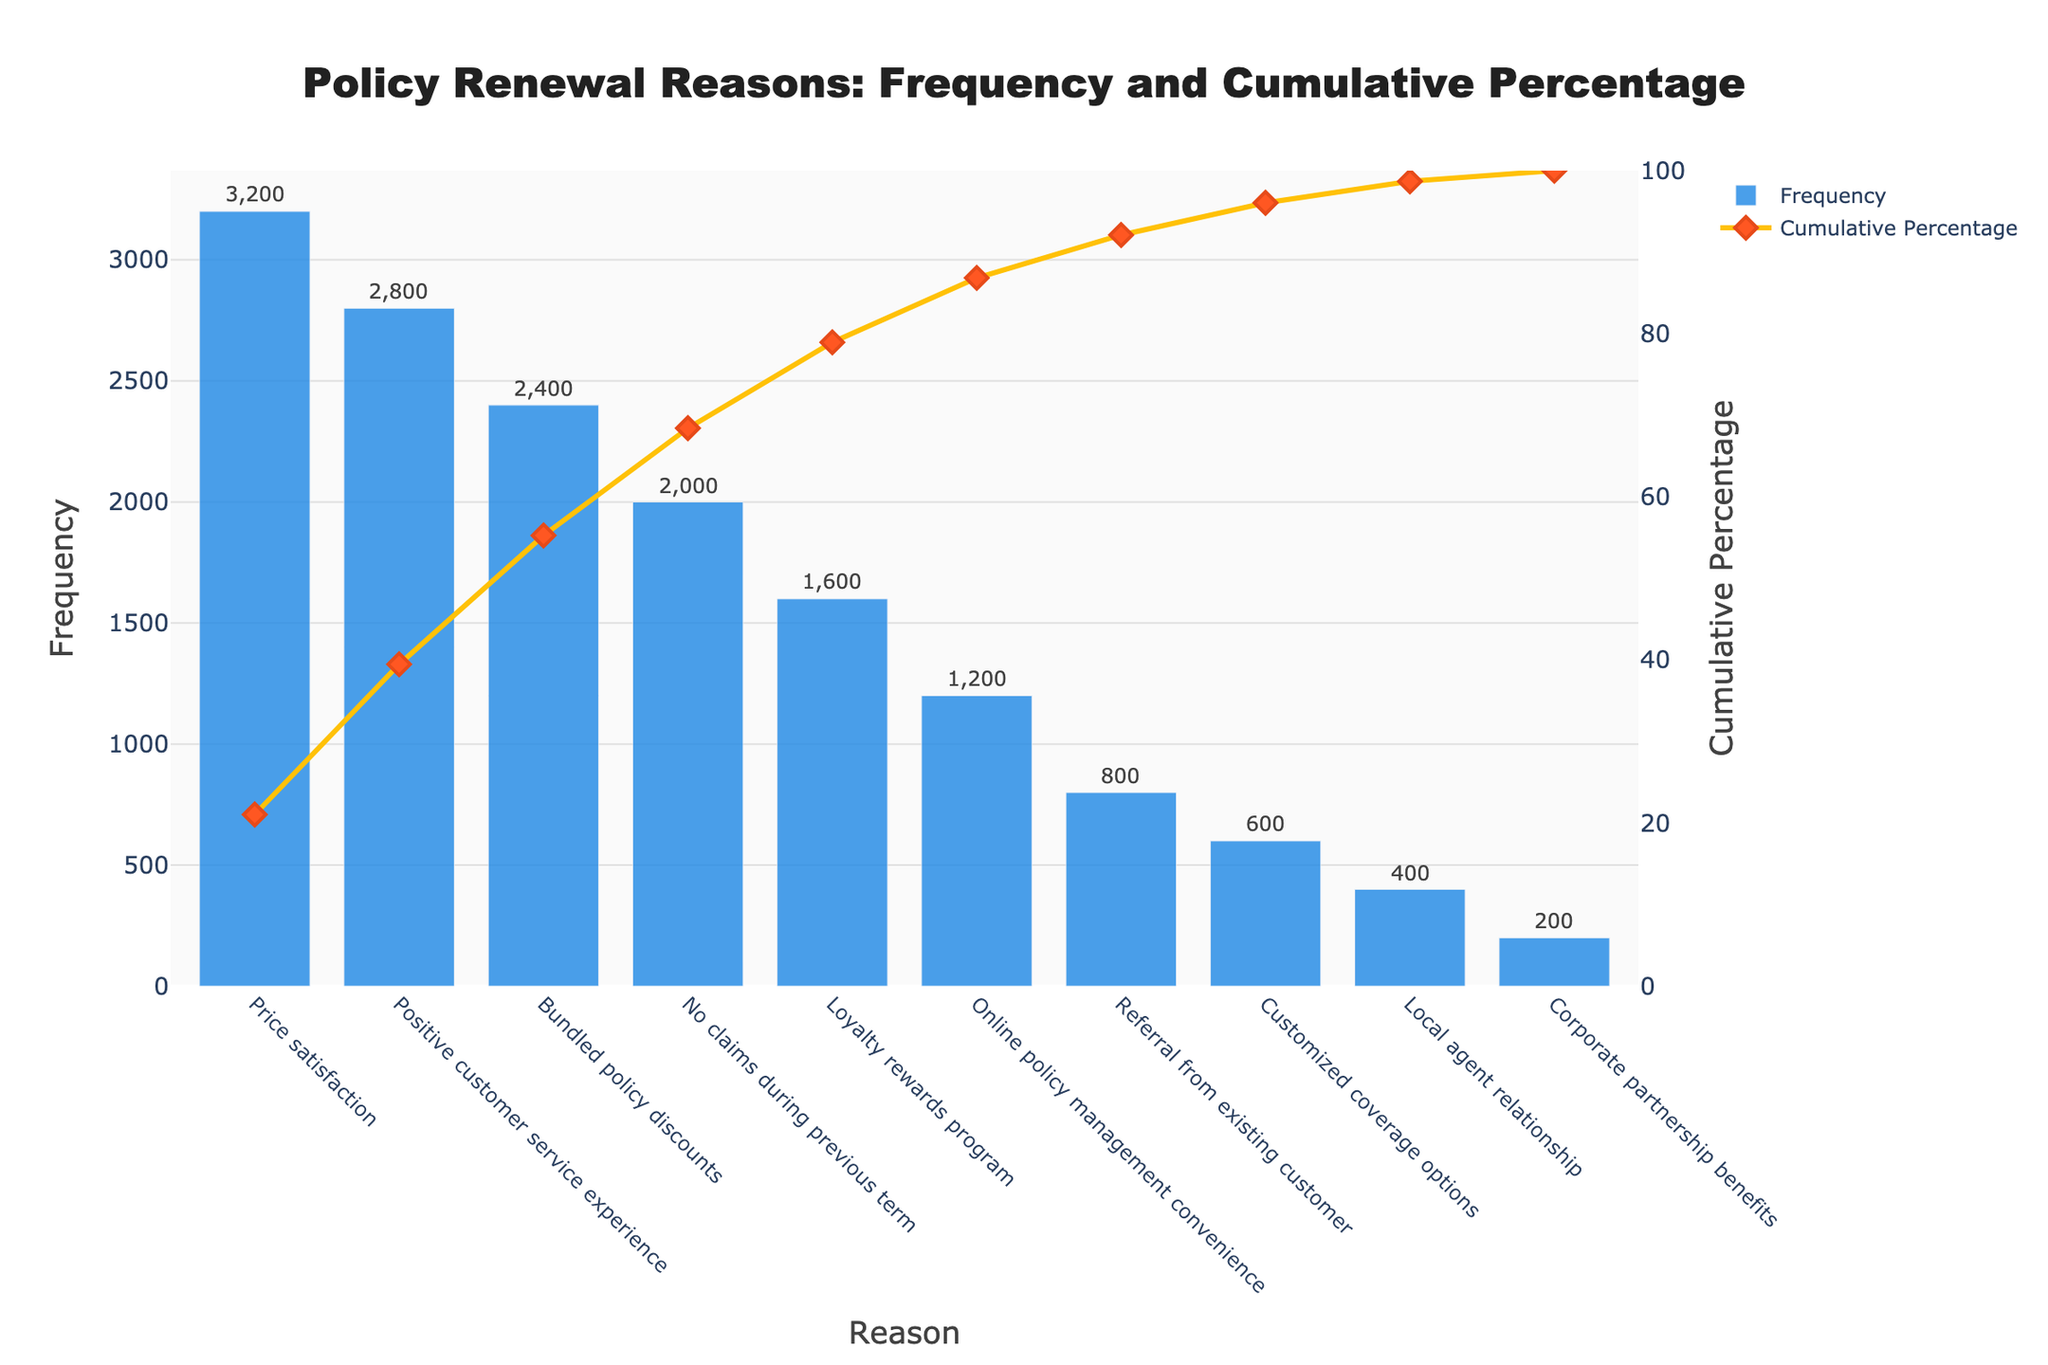What is the title of the chart? The title is displayed at the top center of the chart. It reads "Policy Renewal Reasons: Frequency and Cumulative Percentage".
Answer: Policy Renewal Reasons: Frequency and Cumulative Percentage How many reasons for policy renewal are listed in the chart? Count the number of categories (bars) on the x-axis of the chart to determine the total number of reasons.
Answer: 10 Which reason has the highest frequency? The chart shows the frequency of each reason for policy renewal, with the highest bar representing the highest frequency. "Price satisfaction" is the tallest bar.
Answer: Price satisfaction What is the cumulative percentage after the first three reasons? The cumulative percentage line shows the cumulative frequency as a percentage. Look at the cumulative percentage value at the third reason from the left, "Bundled policy discounts".
Answer: 76% How much cumulative revenue is generated by "Positive customer service experience" and "No claims during previous term"? Using the data, sum the revenue of both reasons: "Positive customer service experience" (1,120,000) + "No claims during previous term" (800,000).
Answer: 1,920,000 What is the difference in frequency between "Loyalty rewards program" and "Online policy management convenience"? Subtract the frequency of "Online policy management convenience" from "Loyalty rewards program": 1600 - 1200 = 400.
Answer: 400 Which reason crosses the 50% cumulative percentage threshold? Identify the bar at which the cumulative percentage line crosses the 50% mark. "Positive customer service experience" coincides with this threshold.
Answer: Positive customer service experience How does the frequency of "Referral from existing customer" compare to "Customized coverage options"? Compare the heights of the bars for these reasons. The bar for "Referral from existing customer" is taller than "Customized coverage options".
Answer: Referral from existing customer is higher By how much does the cumulative percentage increase between "Bundled policy discounts" and "No claims during previous term"? Look at the cumulative percentage values at these points (76% for "Bundled policy discounts" and approximately 88% for "No claims during previous term"). Calculate the difference: 88% - 76%.
Answer: 12% Which reason for renewal has the lowest frequency? The shortest bar on the chart represents the reason with the lowest frequency, which is "Corporate partnership benefits".
Answer: Corporate partnership benefits 